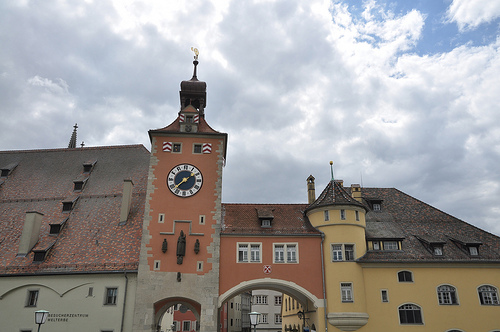Please provide the bounding box coordinate of the region this sentence describes: building has a window. The coordinates for the window on the building are roughly [0.5, 0.65, 0.52, 0.69]. 